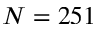Convert formula to latex. <formula><loc_0><loc_0><loc_500><loc_500>N = 2 5 1</formula> 